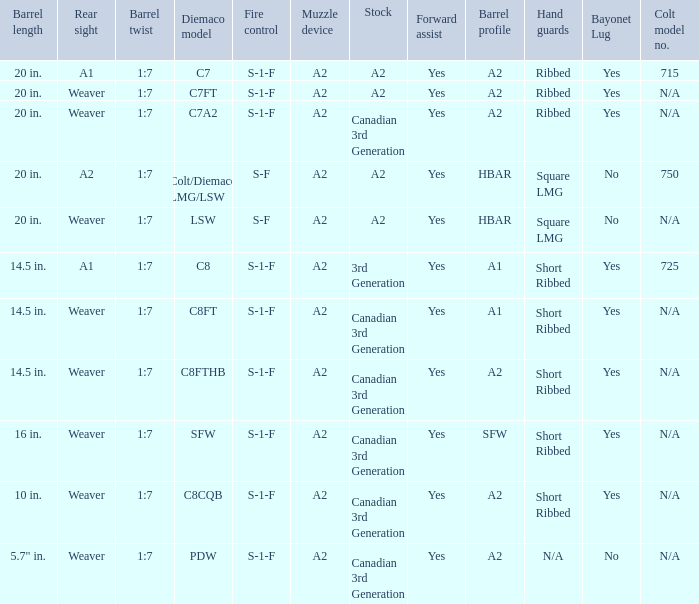Which Barrel twist has a Stock of canadian 3rd generation and a Hand guards of short ribbed? 1:7, 1:7, 1:7, 1:7. 